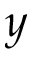<formula> <loc_0><loc_0><loc_500><loc_500>y</formula> 